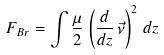Convert formula to latex. <formula><loc_0><loc_0><loc_500><loc_500>F _ { B r } = \int \frac { \mu } { 2 } \, \left ( \frac { d } { d z } \, \vec { \nu } \right ) ^ { 2 } \, d z</formula> 